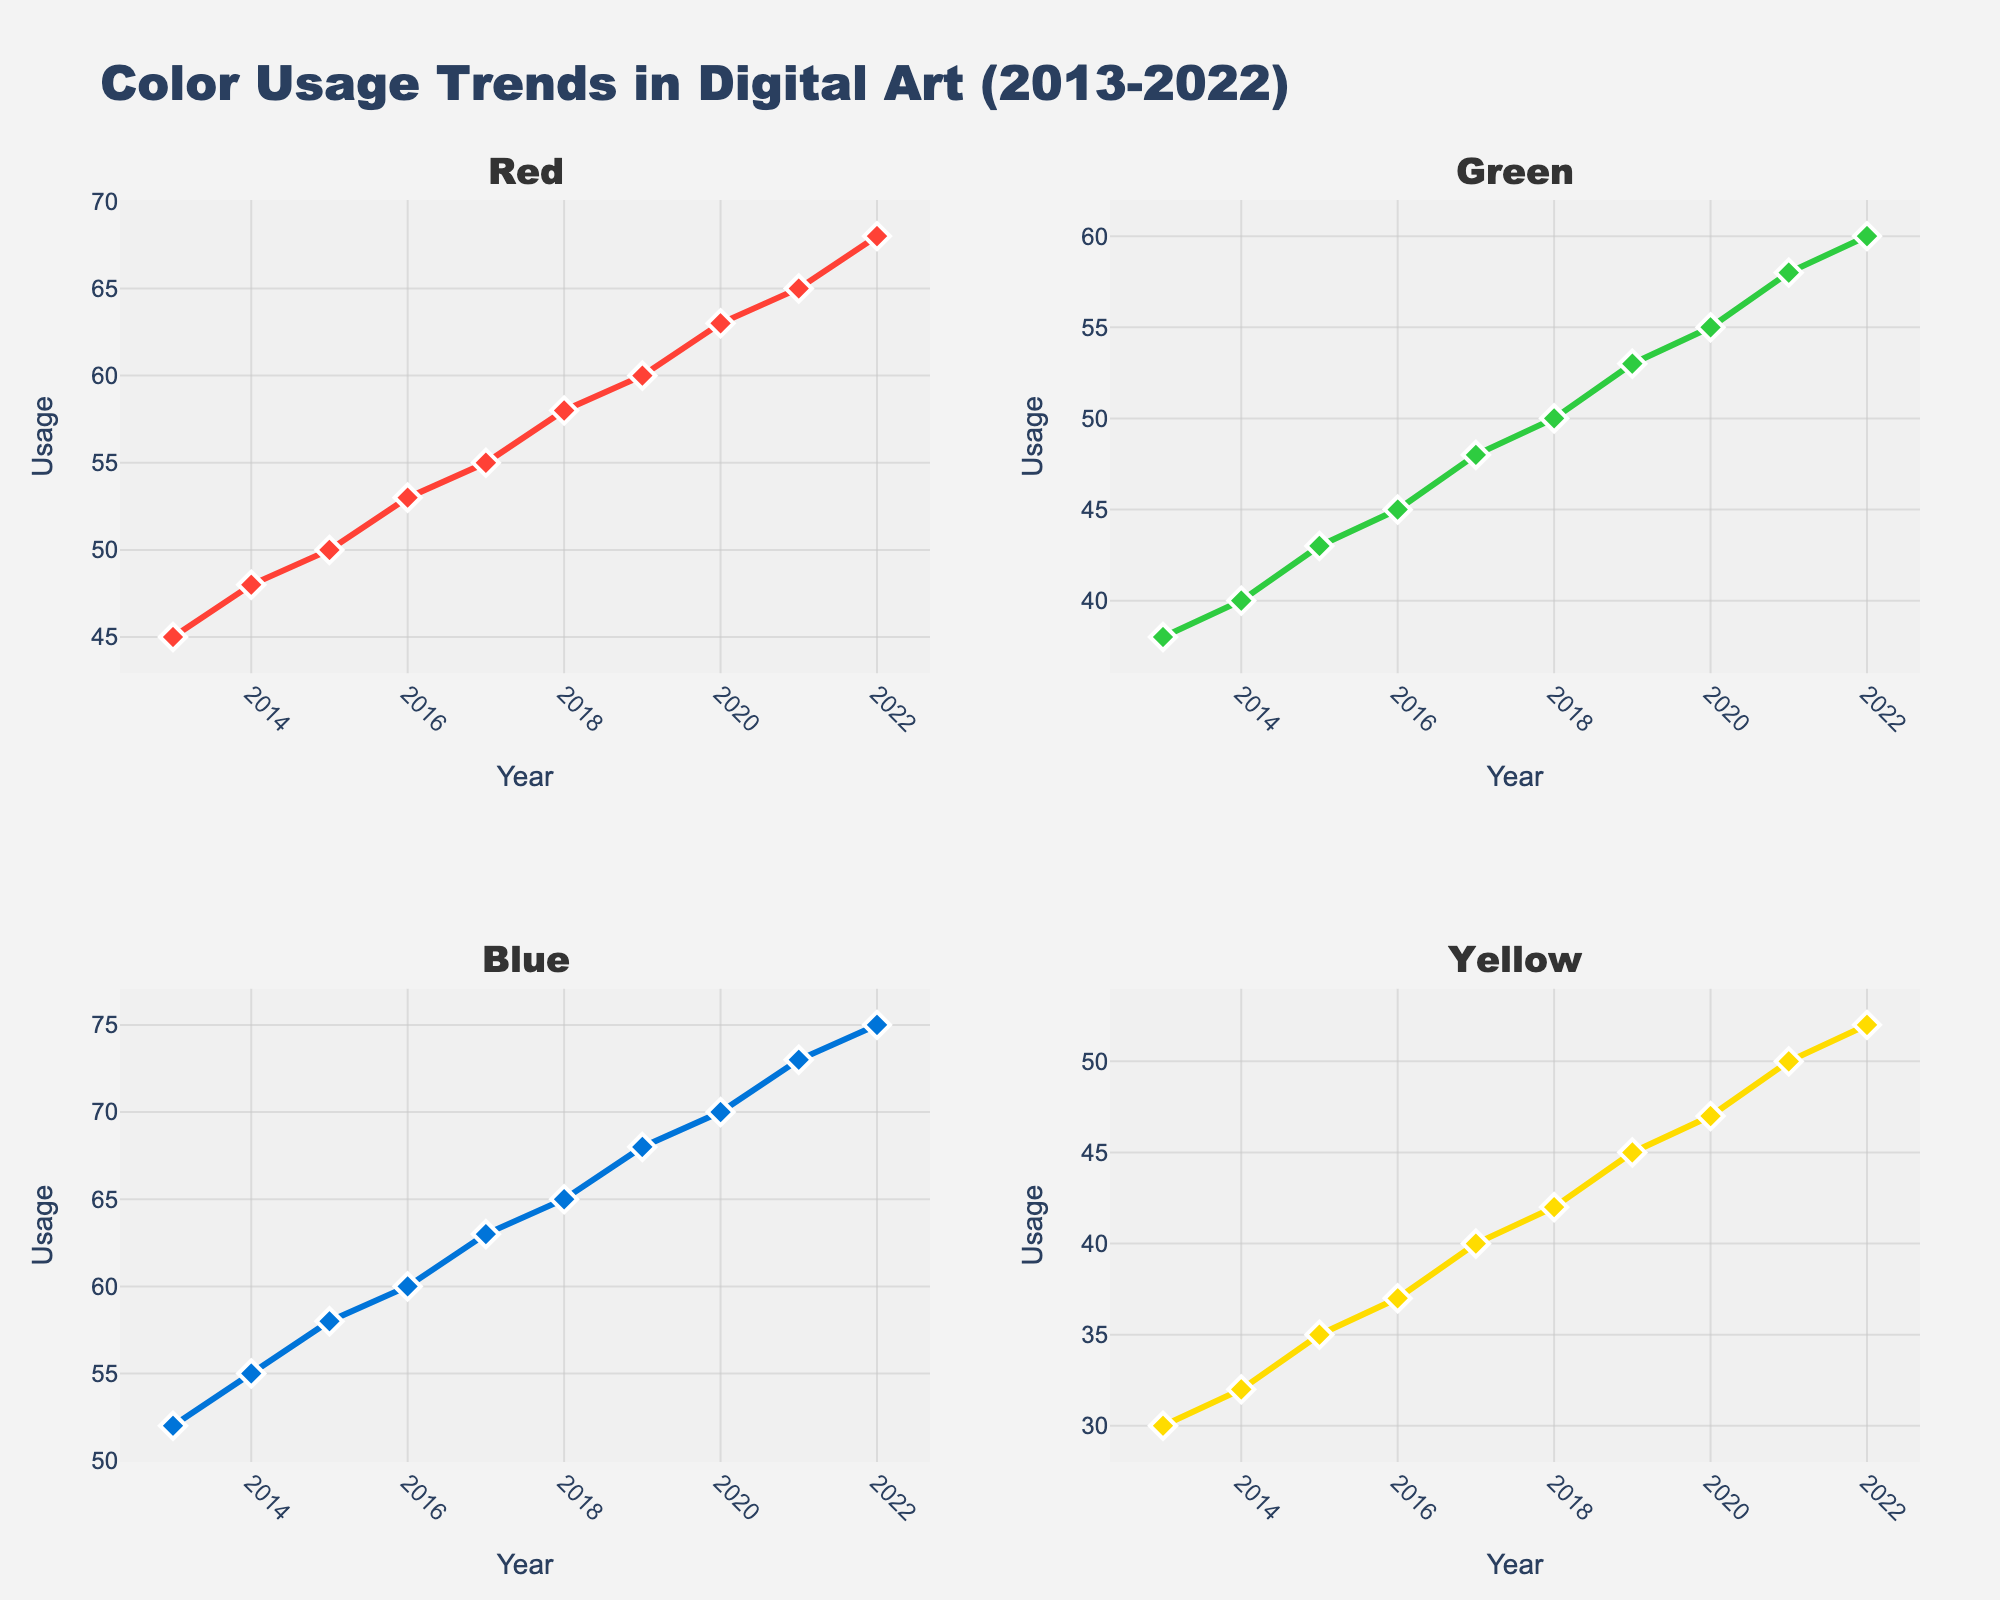What is the title of the figure? The title of the figure can be found at the top of the plot. It provides an overall idea of what the plot represents. Looking at the figure, the title reads "Color Usage Trends in Digital Art (2013-2022)".
Answer: Color Usage Trends in Digital Art (2013-2022) How many subplots are there in the figure? The figure is divided into multiple small plots, known as subplots. According to the layout, there are two rows and two columns, making a total of 4 subplots.
Answer: 4 What is the trend of the usage of the Red color from 2013 to 2022? The line for the Red color in its subplot shows how it changes over time. Observing the Red subplot, the line rises steadily from 45 in 2013 to 68 in 2022, indicating a persistent upward trend.
Answer: Upward trend Which primary color saw the highest usage in 2019? By examining the y-values for each color in 2019 within their respective subplots, the Blue color's subplot shows a value of 68, which is the highest among all primary colors for that year.
Answer: Blue What is the average usage of the Yellow color over the decade? Calculate the average by summing up the Yellow usage values from 2013 to 2022 and then dividing by the number of years (10). The sum is 30 + 32 + 35 + 37 + 40 + 42 + 45 + 47 + 50 + 52 = 410. Divide this by 10 to get 410 / 10.
Answer: 41 Which year shows the largest increase in usage for Green? To find the largest increase, look for the year-to-year difference in the Green subplot. The greatest increase is observed from 2020 to 2021, where usage rises from 55 to 58, a difference of 3 units.
Answer: 2021 Comparing the year 2016, which color had the least usage and by how much? In 2016, compare the values for Red, Green, Blue, and Yellow. Yellow has the least usage at 37. The next lowest is Green at 45. The difference is 45 - 37.
Answer: Yellow, by 8 What is the difference in Blue color usage between 2013 and 2022? Look at the Blue subplot and identify the values for 2013 (52) and 2022 (75). Subtract the value in 2013 from the value in 2022, giving 75 - 52.
Answer: 23 Which primary color exhibited the most consistent upward trend? Examining each subplot, each color shows a consistent upward trend, but visually determining which has the steadiest incremental increase, Red displays a very uniform and steady increment without fluctuations.
Answer: Red 